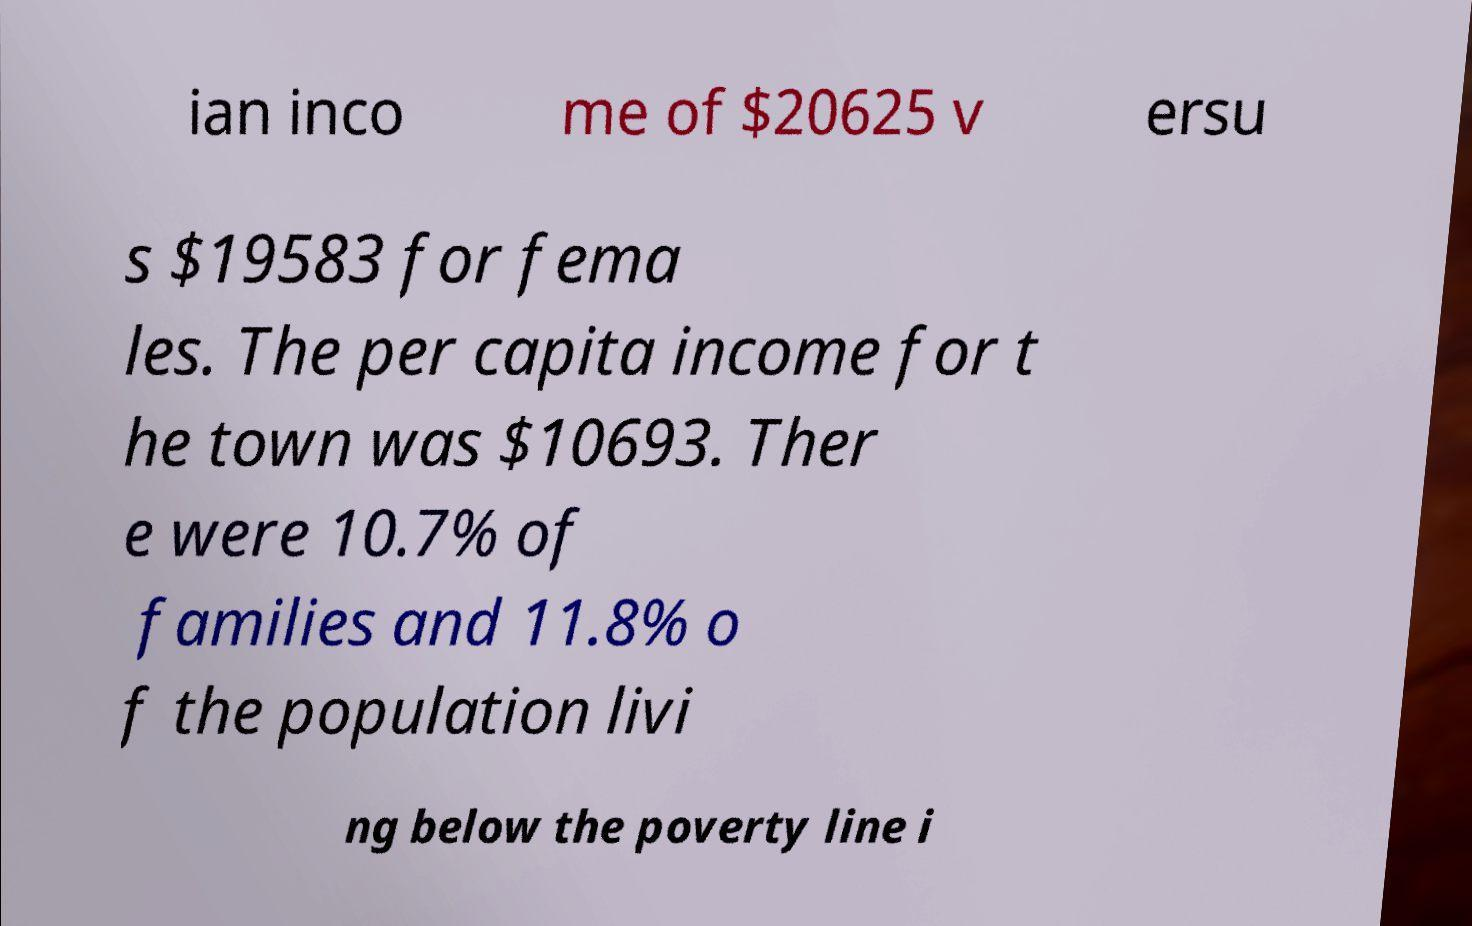Please identify and transcribe the text found in this image. ian inco me of $20625 v ersu s $19583 for fema les. The per capita income for t he town was $10693. Ther e were 10.7% of families and 11.8% o f the population livi ng below the poverty line i 